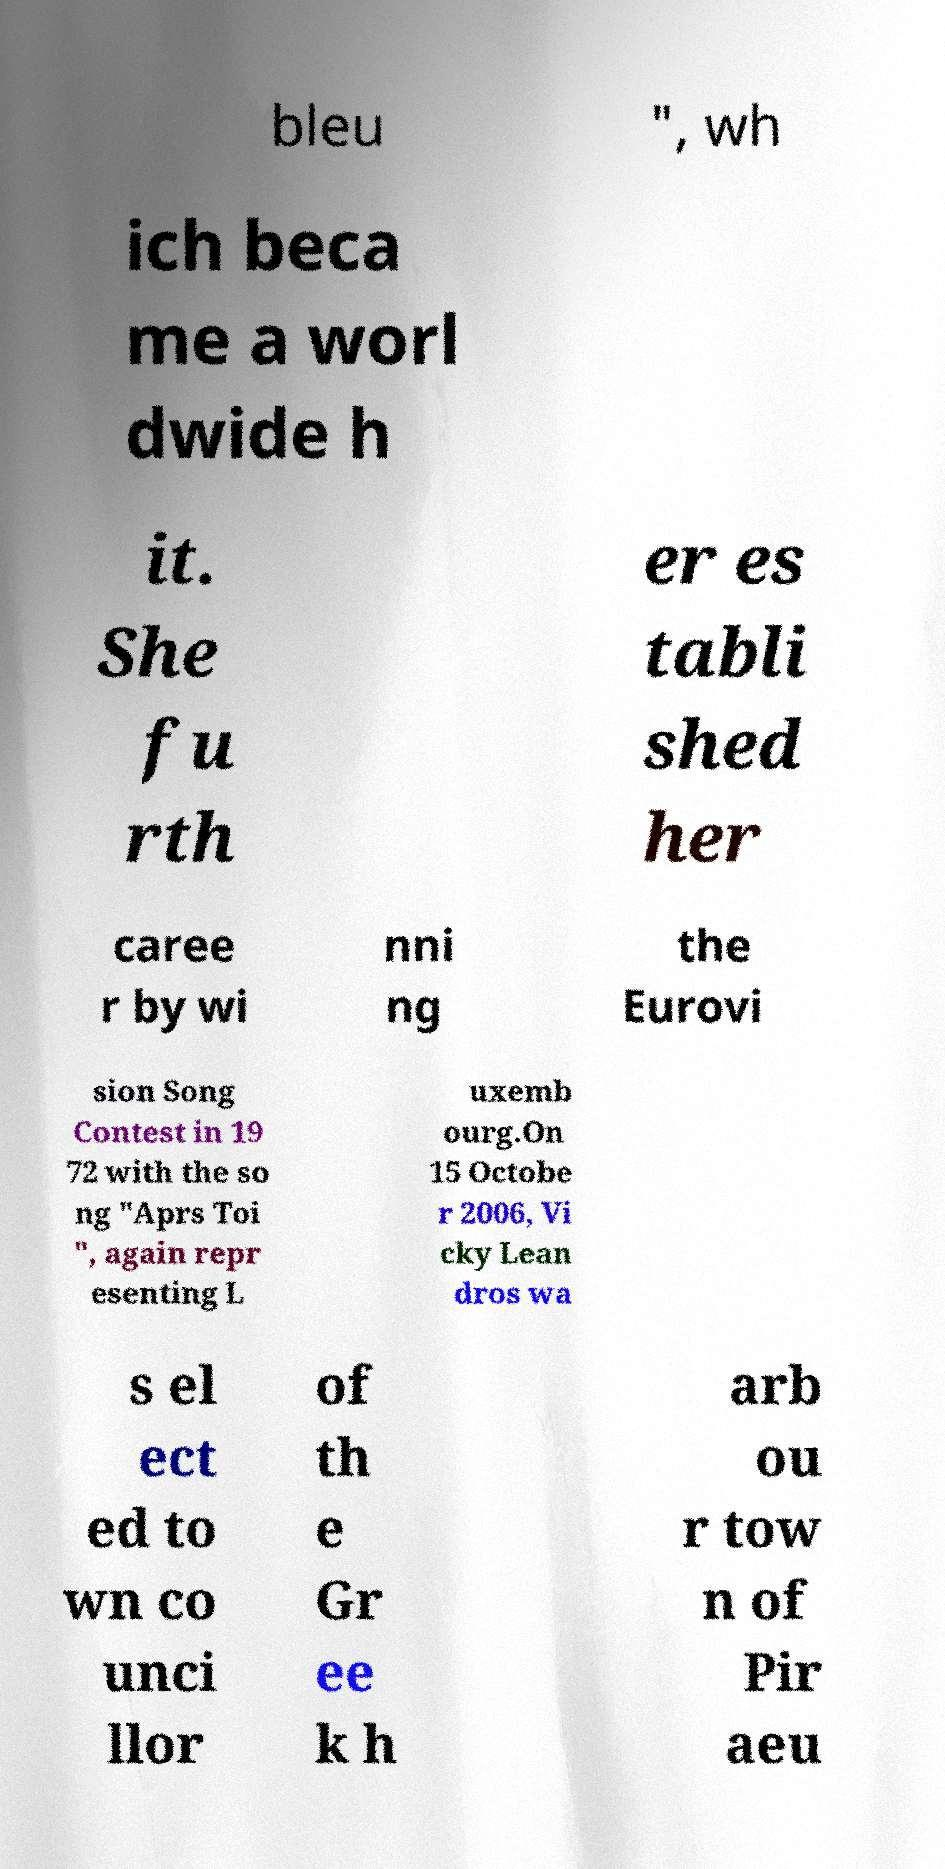For documentation purposes, I need the text within this image transcribed. Could you provide that? bleu ", wh ich beca me a worl dwide h it. She fu rth er es tabli shed her caree r by wi nni ng the Eurovi sion Song Contest in 19 72 with the so ng "Aprs Toi ", again repr esenting L uxemb ourg.On 15 Octobe r 2006, Vi cky Lean dros wa s el ect ed to wn co unci llor of th e Gr ee k h arb ou r tow n of Pir aeu 